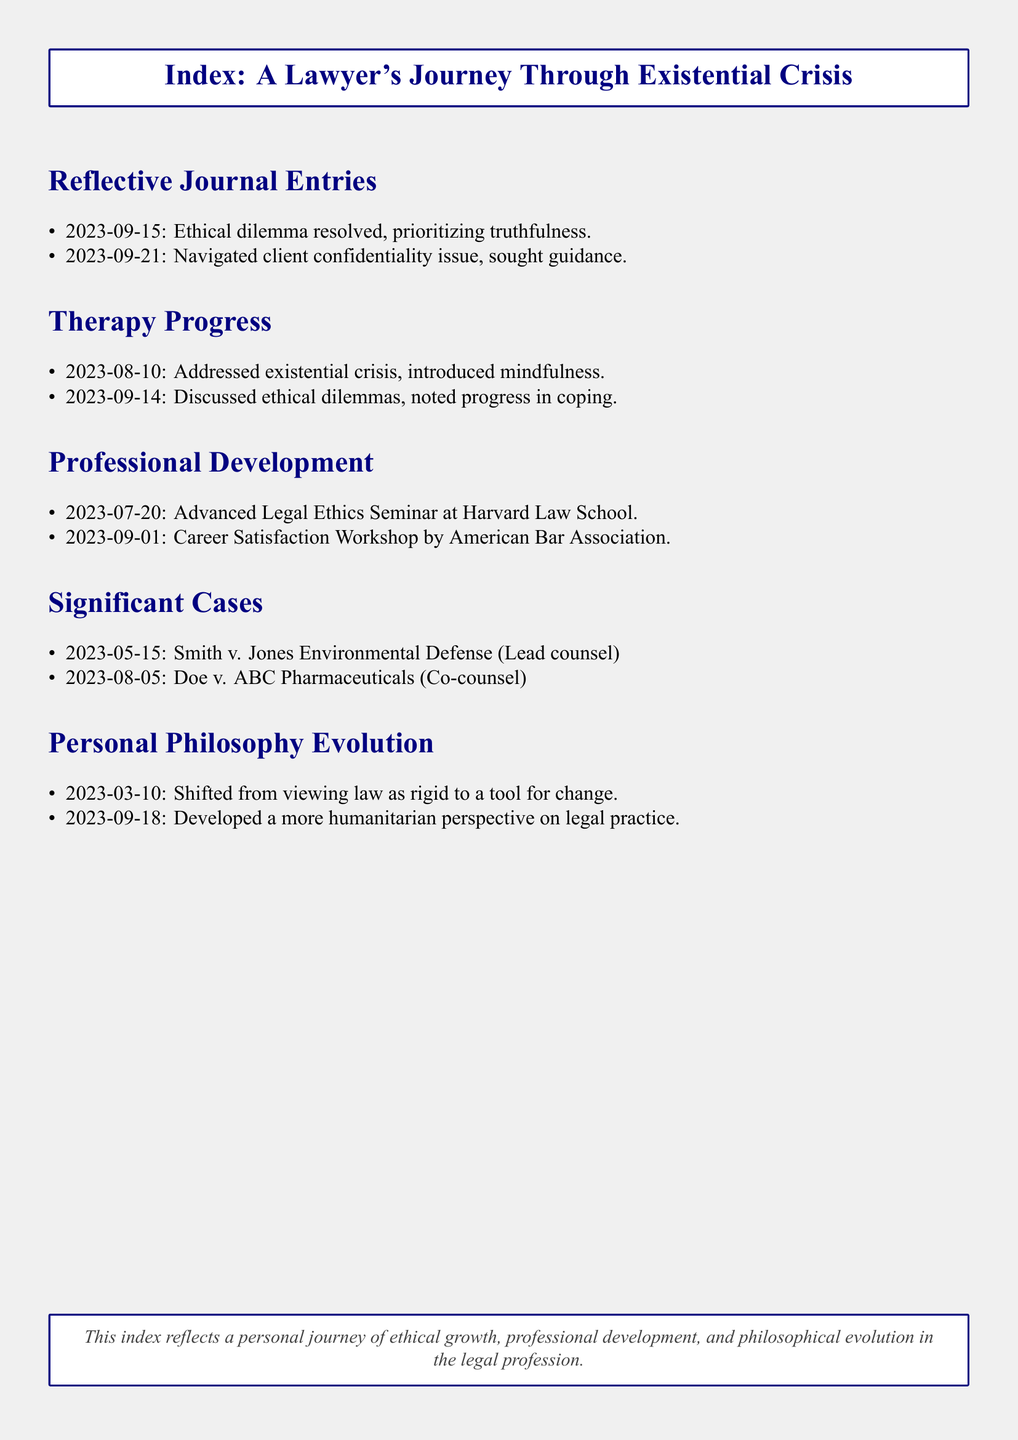What date was the ethical dilemma resolved? The date noted for resolving the ethical dilemma in the journal entries section is September 15, 2023.
Answer: September 15, 2023 What was discussed in the therapy session on August 10, 2023? The therapy session on August 10, 2023, focused on addressing the existential crisis and introducing mindfulness.
Answer: Addressed existential crisis, introduced mindfulness Who was the lead counsel for the case Smith v. Jones Environmental Defense? The lead counsel for the case was explicitly stated as the individual documenting the entries.
Answer: Lead counsel What significant change occurred in personal philosophy on March 10, 2023? On March 10, 2023, there was a shift in view from seeing the law as rigid to a tool for change.
Answer: Shifted from viewing law as rigid to a tool for change How many professional development activities are documented? The total number of professional development activities listed in the document is two.
Answer: Two What is the overarching theme reflected in this index? The index encapsulates themes of ethical growth, professional development, and philosophical evolution.
Answer: Ethical growth, professional development, philosophical evolution 